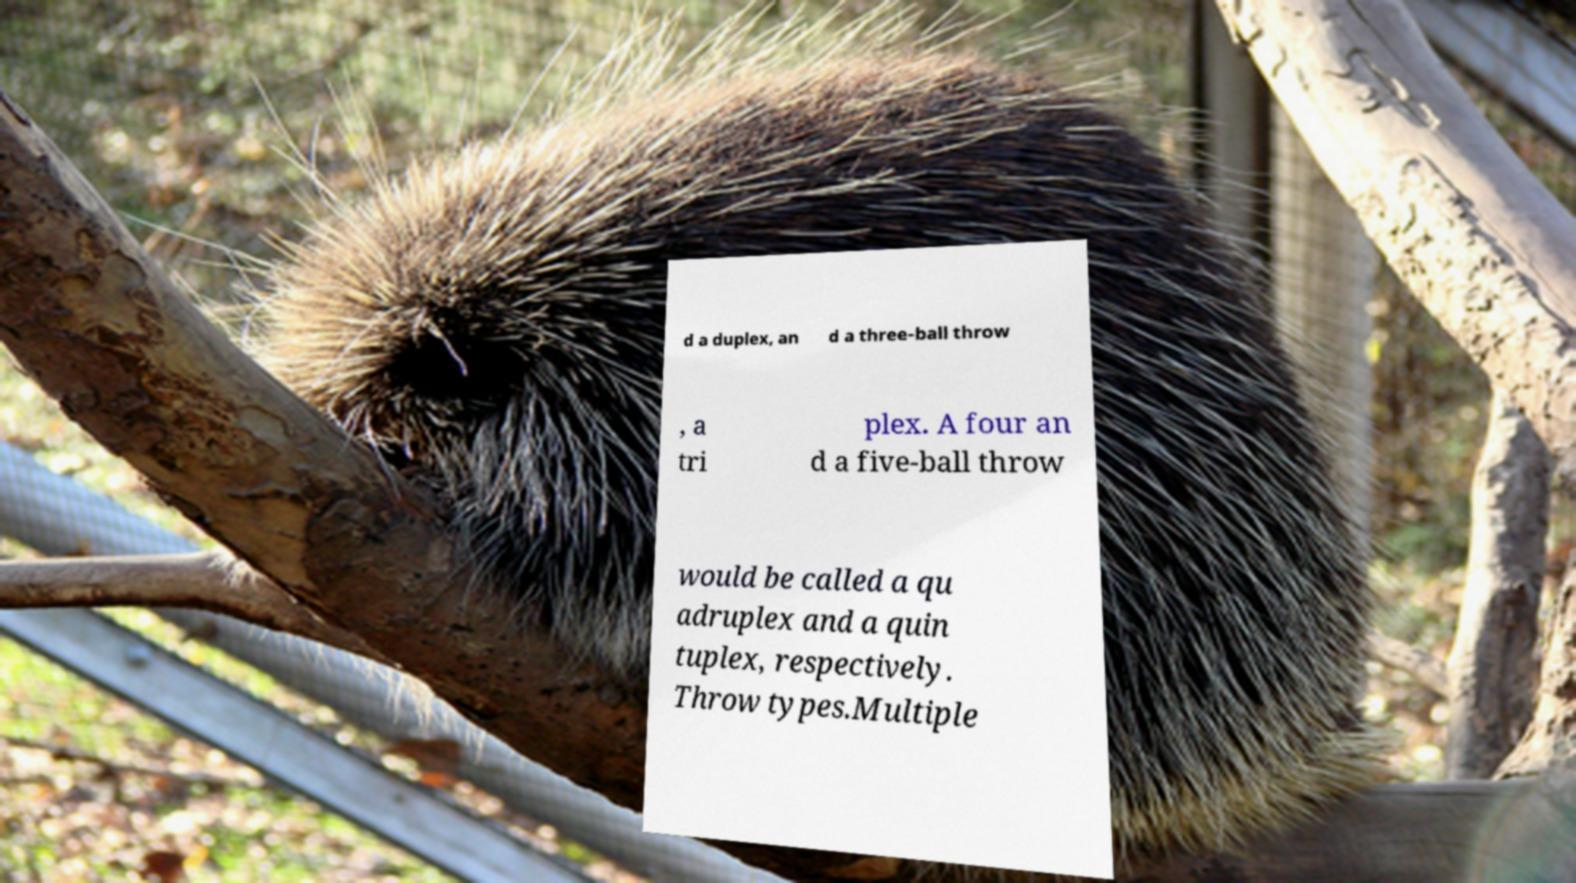Please read and relay the text visible in this image. What does it say? d a duplex, an d a three-ball throw , a tri plex. A four an d a five-ball throw would be called a qu adruplex and a quin tuplex, respectively. Throw types.Multiple 